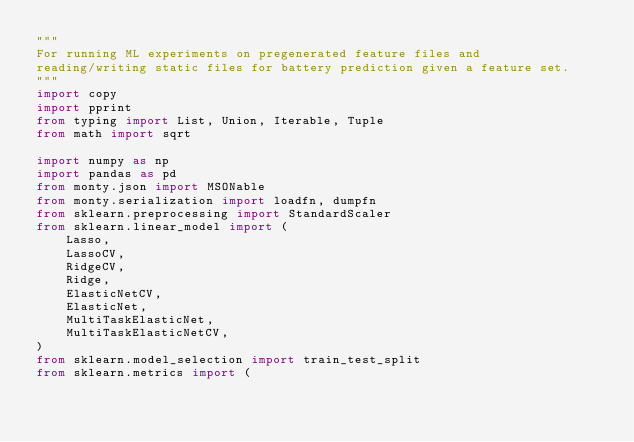Convert code to text. <code><loc_0><loc_0><loc_500><loc_500><_Python_>"""
For running ML experiments on pregenerated feature files and
reading/writing static files for battery prediction given a feature set.
"""
import copy
import pprint
from typing import List, Union, Iterable, Tuple
from math import sqrt

import numpy as np
import pandas as pd
from monty.json import MSONable
from monty.serialization import loadfn, dumpfn
from sklearn.preprocessing import StandardScaler
from sklearn.linear_model import (
    Lasso,
    LassoCV,
    RidgeCV,
    Ridge,
    ElasticNetCV,
    ElasticNet,
    MultiTaskElasticNet,
    MultiTaskElasticNetCV,
)
from sklearn.model_selection import train_test_split
from sklearn.metrics import (</code> 